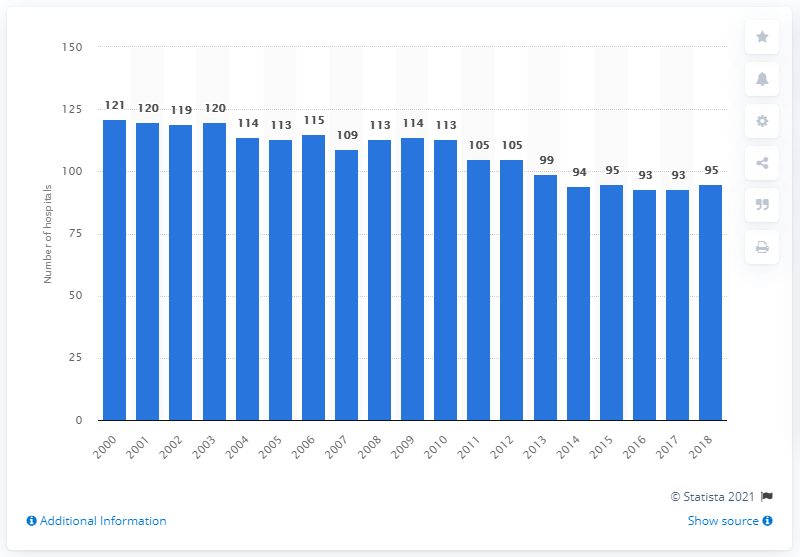Draw attention to some important aspects in this diagram. In 2018, there were 95 hospitals in Lithuania. 